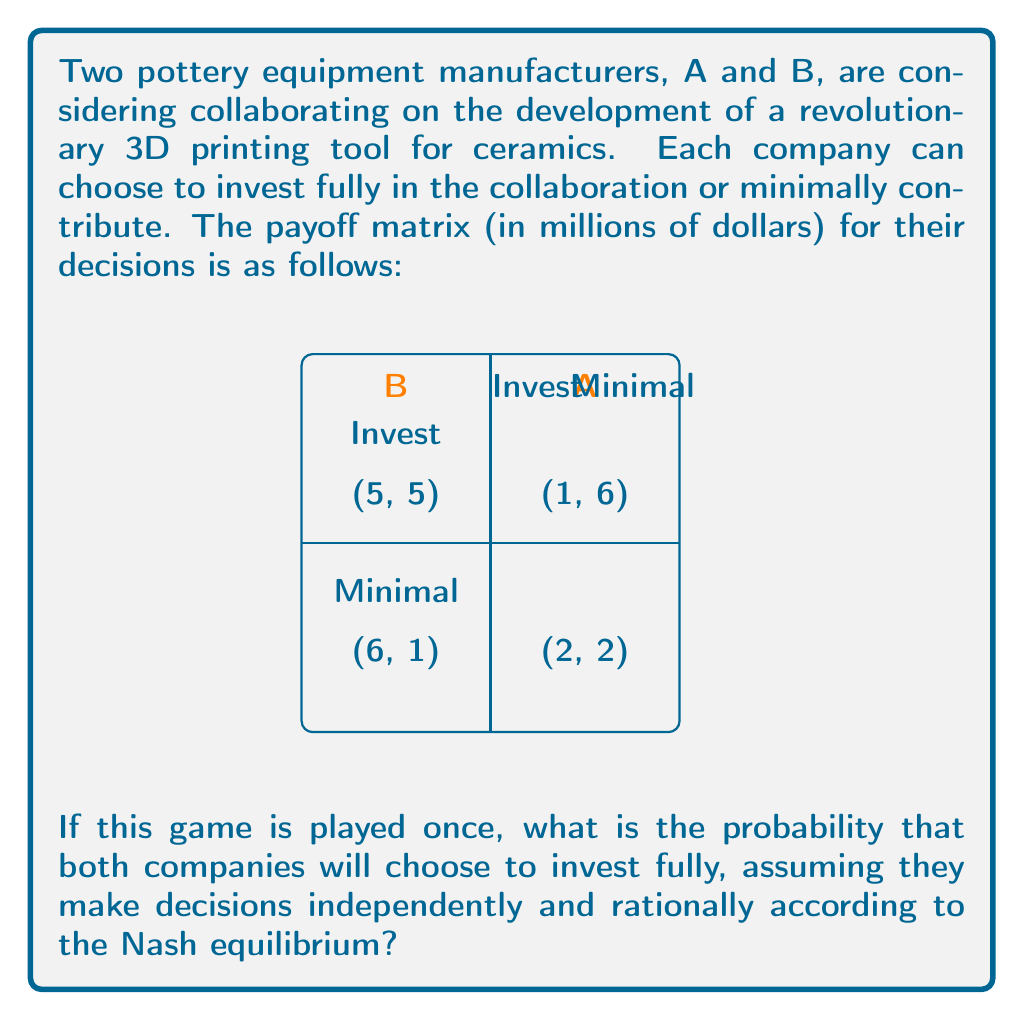Teach me how to tackle this problem. To solve this problem, we need to analyze the Prisoner's Dilemma in the context of collaborative pottery tool development. Let's approach this step-by-step:

1) First, we need to identify the Nash equilibrium in this game. A Nash equilibrium occurs when each player's strategy is optimal given the other player's strategy.

2) For Company A:
   - If B invests, A gets $5 million by investing or $6 million by minimal contribution.
   - If B contributes minimally, A gets $1 million by investing or $2 million by minimal contribution.
   In both cases, A's best response is to contribute minimally.

3) For Company B:
   - If A invests, B gets $5 million by investing or $6 million by minimal contribution.
   - If A contributes minimally, B gets $1 million by investing or $2 million by minimal contribution.
   In both cases, B's best response is to contribute minimally.

4) Therefore, the Nash equilibrium is (Minimal, Minimal), resulting in a payoff of (2, 2).

5) This is a classic Prisoner's Dilemma scenario. Despite the fact that both companies would be better off if they both invested (payoff of 5 each), the rational strategy for each company is to contribute minimally.

6) Given that both companies will rationally choose to contribute minimally in a one-shot game, the probability of both investing is 0.

7) We can express this mathematically as:

   $$P(\text{Both Invest}) = P(A \text{ Invests}) \times P(B \text{ Invests}) = 0 \times 0 = 0$$

Therefore, assuming rational play according to the Nash equilibrium, the probability of both companies choosing to invest fully is 0.
Answer: 0 